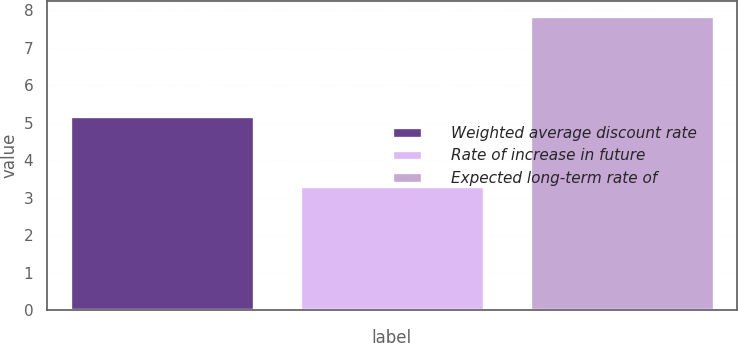Convert chart. <chart><loc_0><loc_0><loc_500><loc_500><bar_chart><fcel>Weighted average discount rate<fcel>Rate of increase in future<fcel>Expected long-term rate of<nl><fcel>5.17<fcel>3.3<fcel>7.84<nl></chart> 